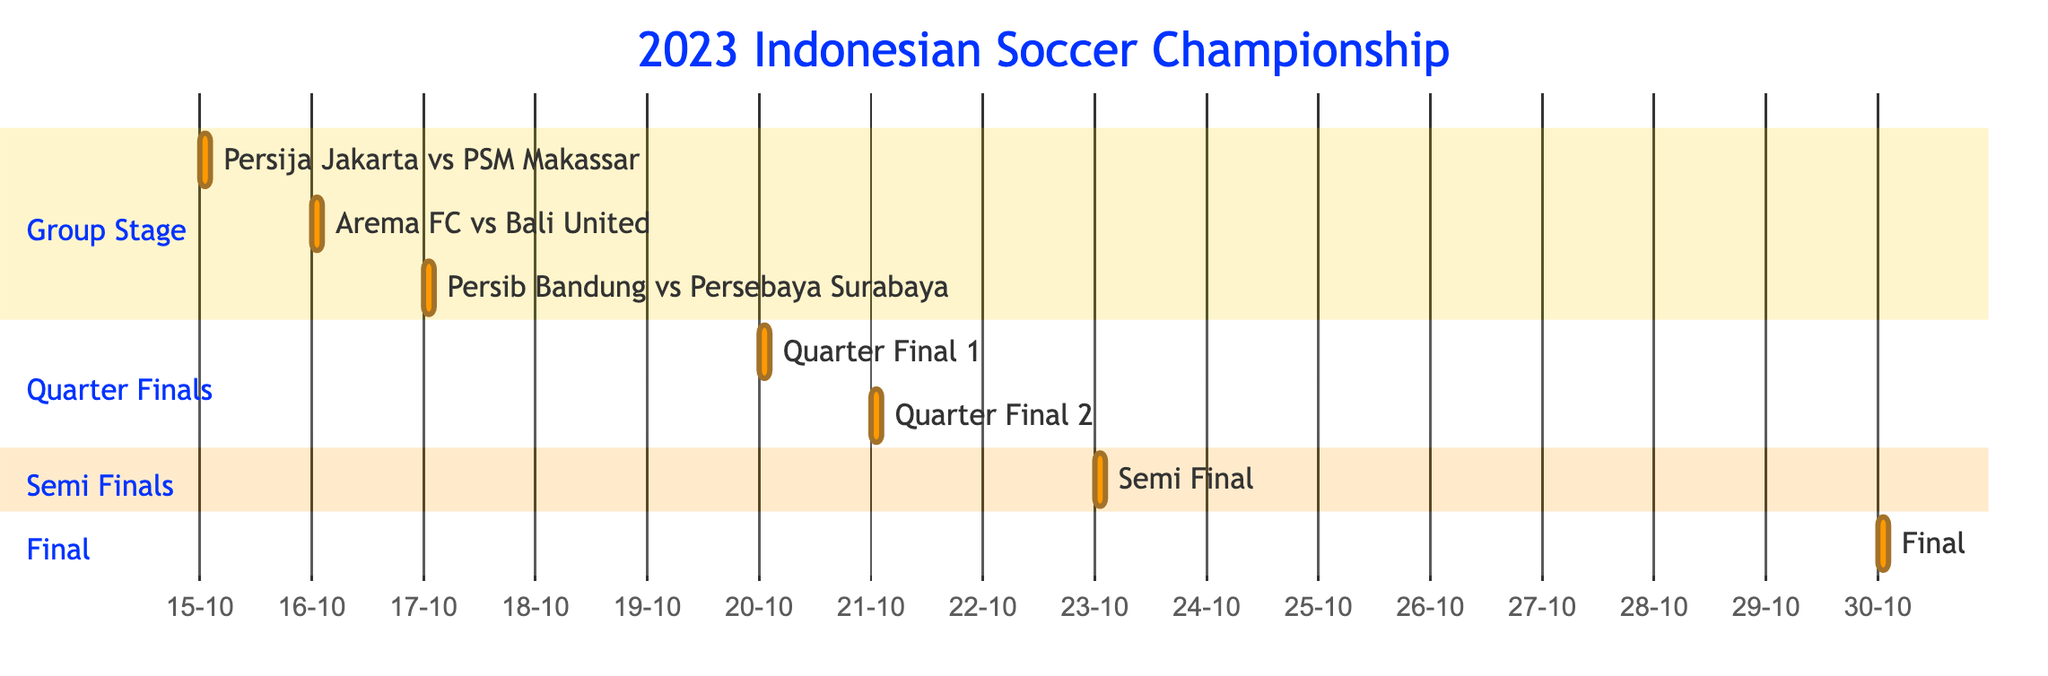What is the first match of the tournament? The first match in the schedule is "Persija Jakarta vs PSM Makassar," which occurs on the date of the first entry in the Group Stage section.
Answer: Persija Jakarta vs PSM Makassar How many matches are scheduled in the Group Stage? By counting the entries in the Group Stage section of the diagram, there are three matches listed: "Persija Jakarta vs PSM Makassar," "Arema FC vs Bali United," and "Persib Bandung vs Persebaya Surabaya."
Answer: 3 What time does the last match of the tournament start? The last match in the diagram is the "Final," which starts at 19:00 on the date indicated for the Final entry.
Answer: 19:00 On what date is the Semi-Final match scheduled? The Semi-Final match is on "2023-10-23," as shown in the corresponding section of the diagram.
Answer: 2023-10-23 Which match has the earliest start time across all matches? By comparing the start times of all matches, the earliest match is "Arema FC vs Bali United," which starts at 18:00 on the date of its entry in the Group Stage section.
Answer: Arema FC vs Bali United 